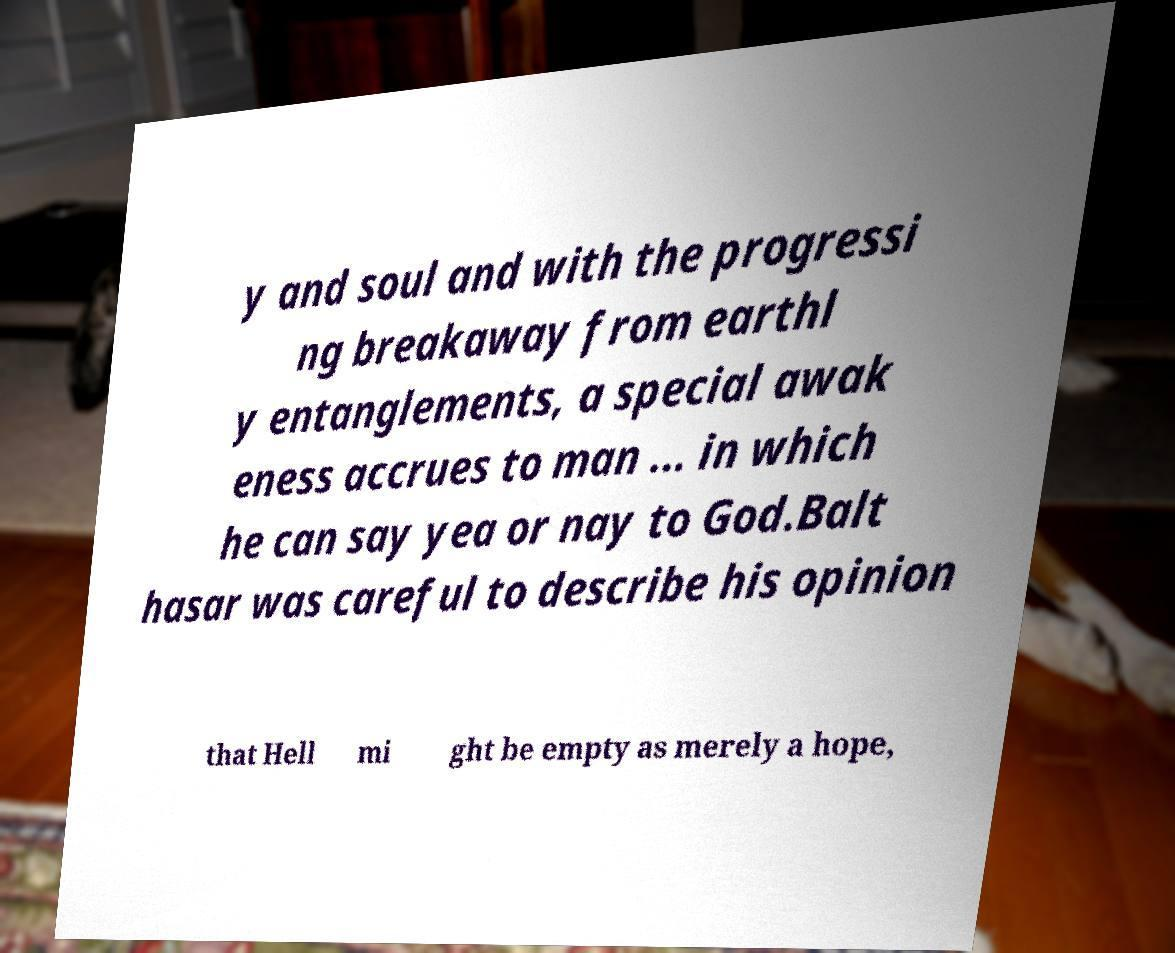Could you assist in decoding the text presented in this image and type it out clearly? y and soul and with the progressi ng breakaway from earthl y entanglements, a special awak eness accrues to man ... in which he can say yea or nay to God.Balt hasar was careful to describe his opinion that Hell mi ght be empty as merely a hope, 